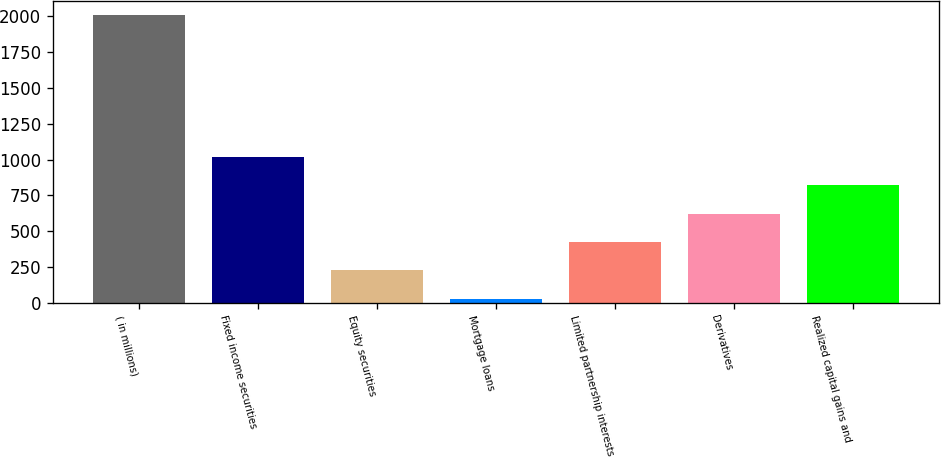Convert chart. <chart><loc_0><loc_0><loc_500><loc_500><bar_chart><fcel>( in millions)<fcel>Fixed income securities<fcel>Equity securities<fcel>Mortgage loans<fcel>Limited partnership interests<fcel>Derivatives<fcel>Realized capital gains and<nl><fcel>2011<fcel>1019<fcel>225.4<fcel>27<fcel>423.8<fcel>622.2<fcel>820.6<nl></chart> 